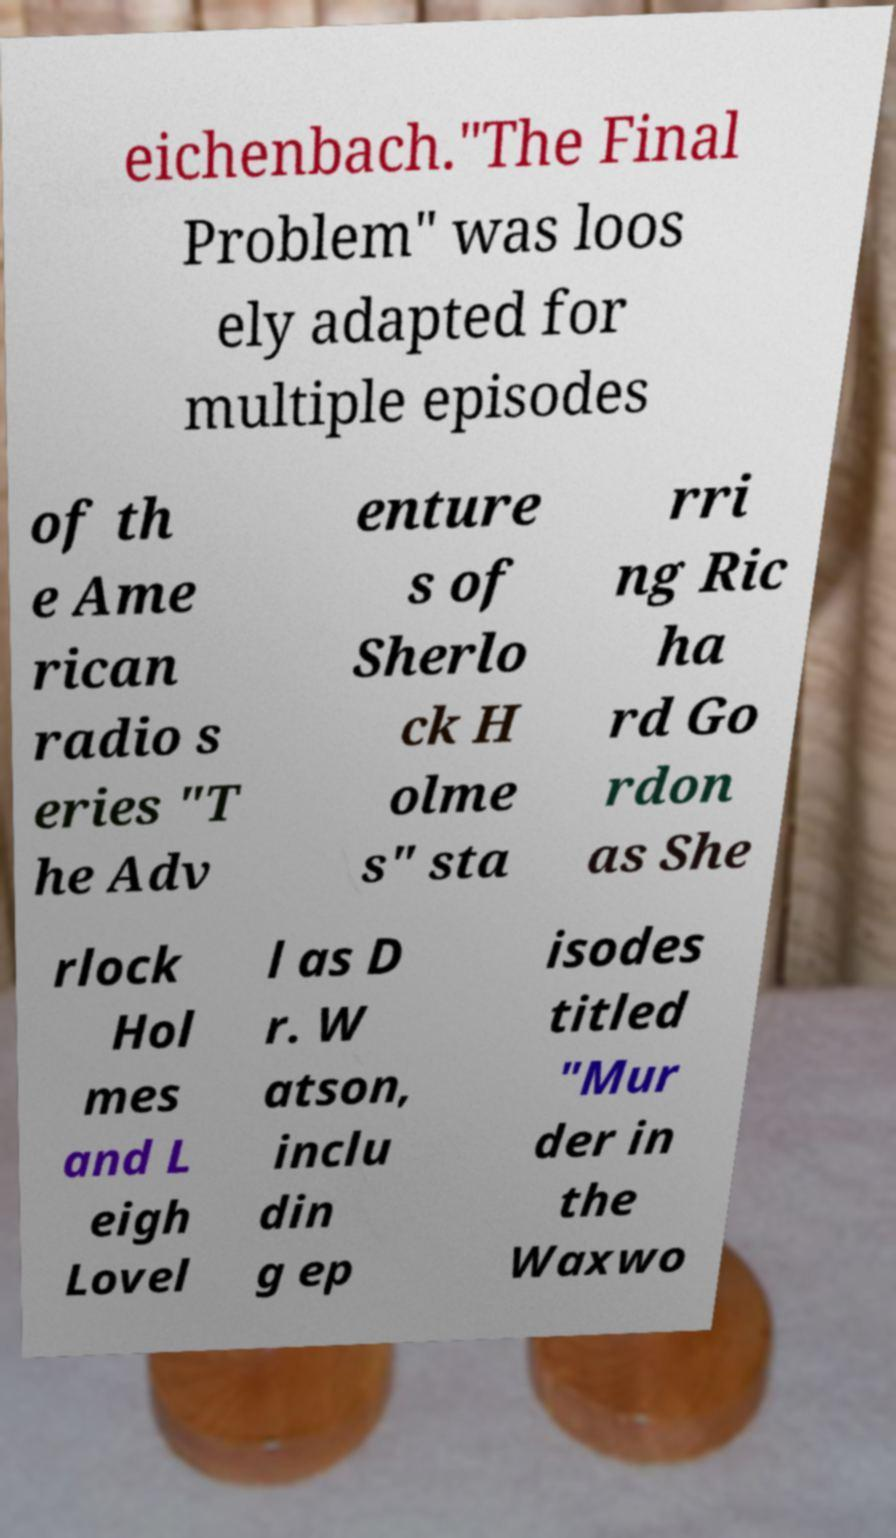I need the written content from this picture converted into text. Can you do that? eichenbach."The Final Problem" was loos ely adapted for multiple episodes of th e Ame rican radio s eries "T he Adv enture s of Sherlo ck H olme s" sta rri ng Ric ha rd Go rdon as She rlock Hol mes and L eigh Lovel l as D r. W atson, inclu din g ep isodes titled "Mur der in the Waxwo 